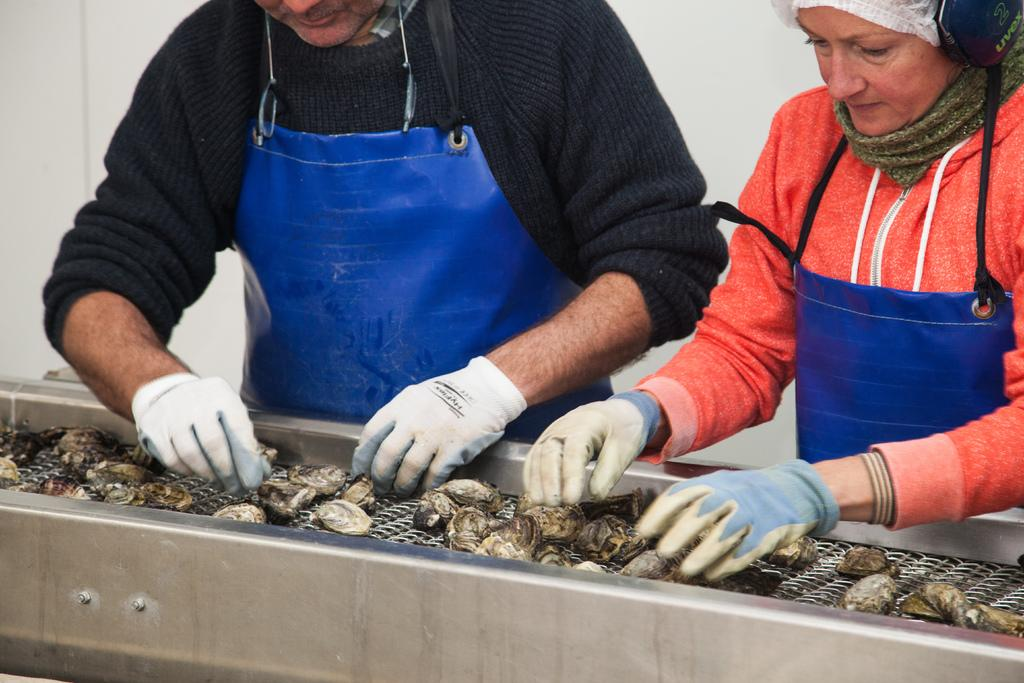How many people are in the image? There are two persons standing in the image. What are the persons wearing on their hands? The persons are wearing gloves. What type of seafood can be seen in the image? There are cockles on an object in the image. How many giraffes can be seen in the image? There are no giraffes present in the image. What type of metal is used to make the object with cockles in the image? The provided facts do not mention the material of the object with cockles, so it cannot be determined from the image. 